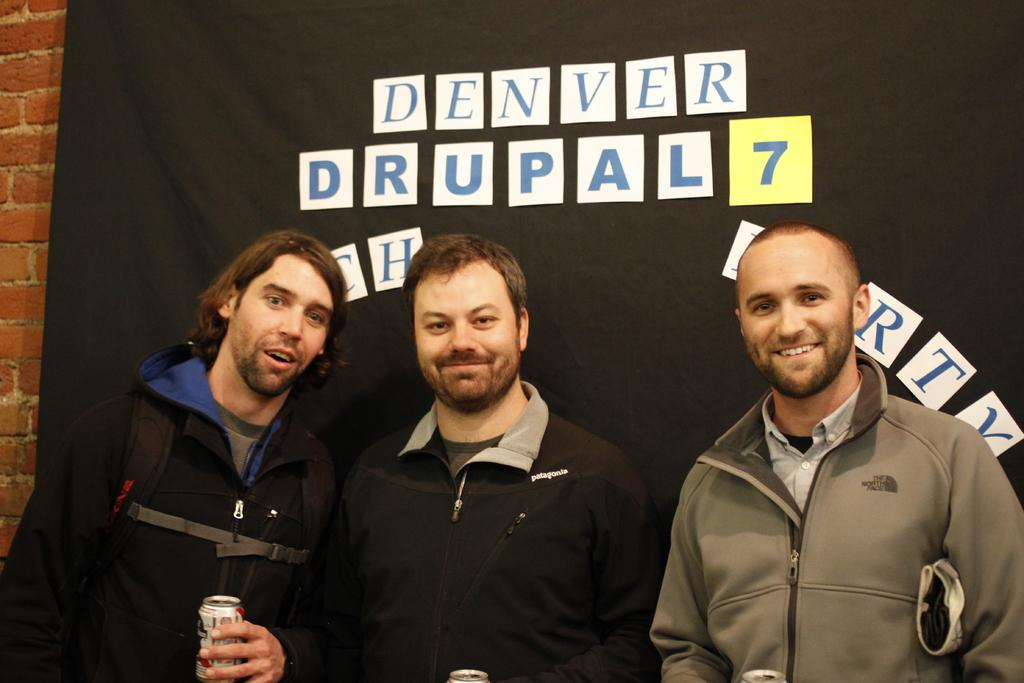<image>
Present a compact description of the photo's key features. Three bearded men pose for the picture in front of a black tarp with a sign that has "Denver" on it. 